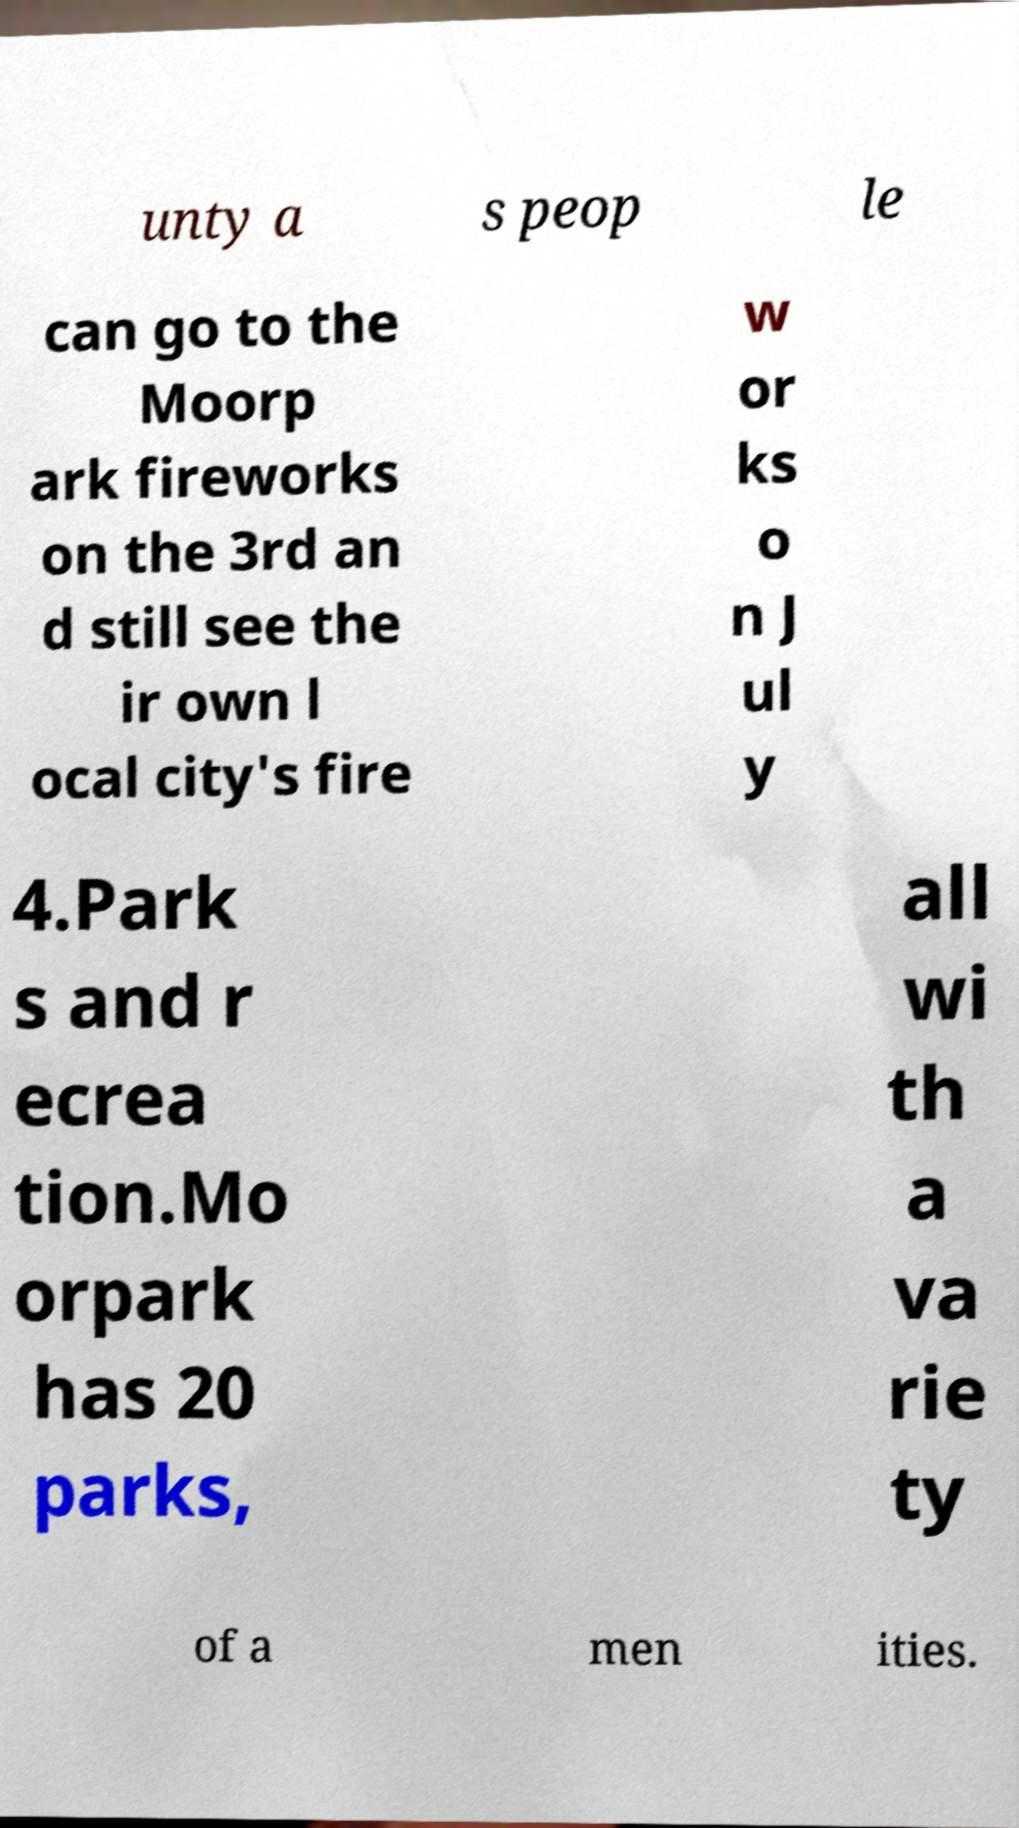I need the written content from this picture converted into text. Can you do that? unty a s peop le can go to the Moorp ark fireworks on the 3rd an d still see the ir own l ocal city's fire w or ks o n J ul y 4.Park s and r ecrea tion.Mo orpark has 20 parks, all wi th a va rie ty of a men ities. 